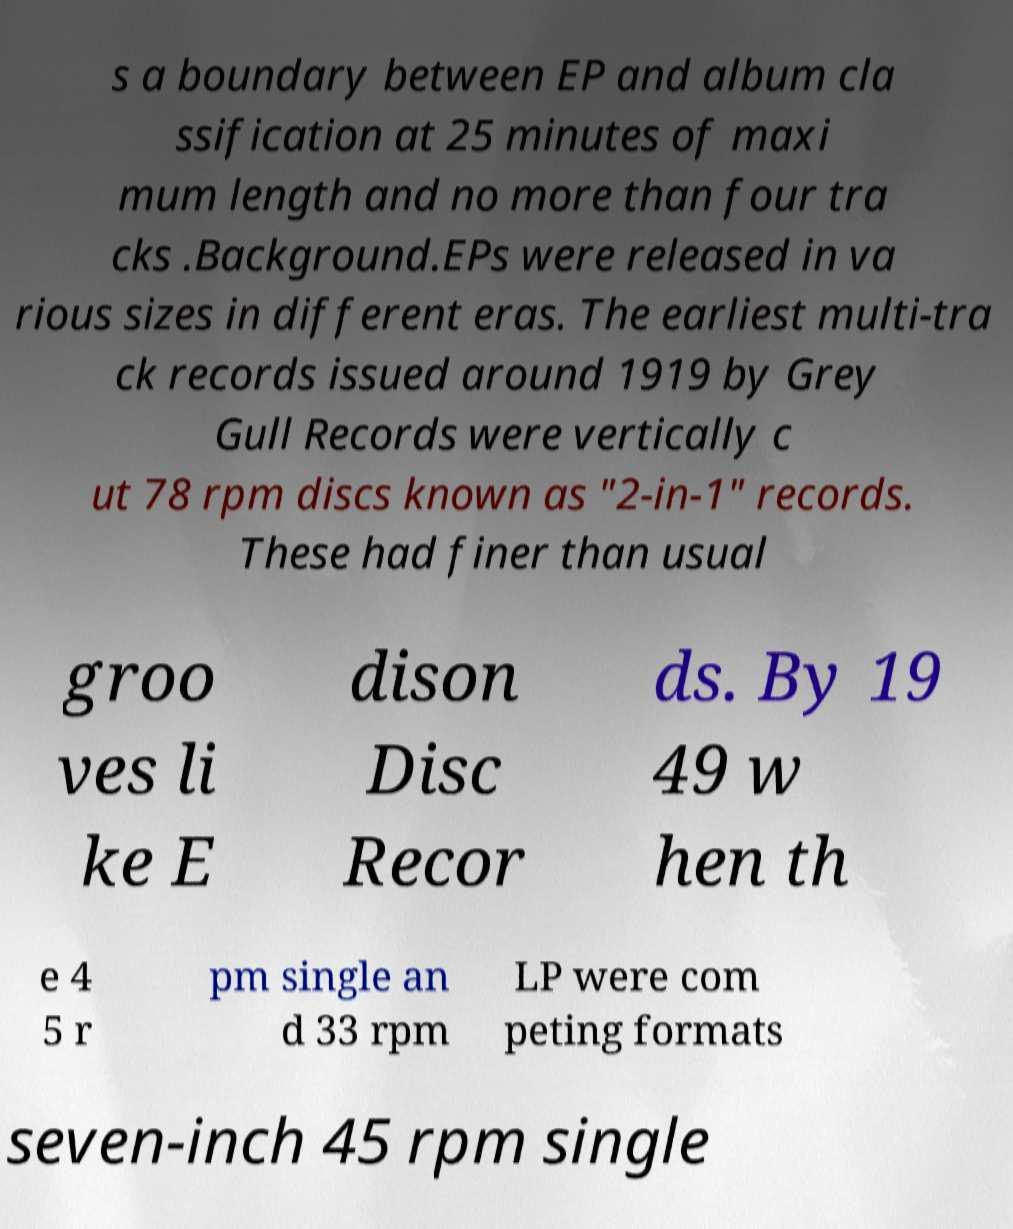Please read and relay the text visible in this image. What does it say? s a boundary between EP and album cla ssification at 25 minutes of maxi mum length and no more than four tra cks .Background.EPs were released in va rious sizes in different eras. The earliest multi-tra ck records issued around 1919 by Grey Gull Records were vertically c ut 78 rpm discs known as "2-in-1" records. These had finer than usual groo ves li ke E dison Disc Recor ds. By 19 49 w hen th e 4 5 r pm single an d 33 rpm LP were com peting formats seven-inch 45 rpm single 